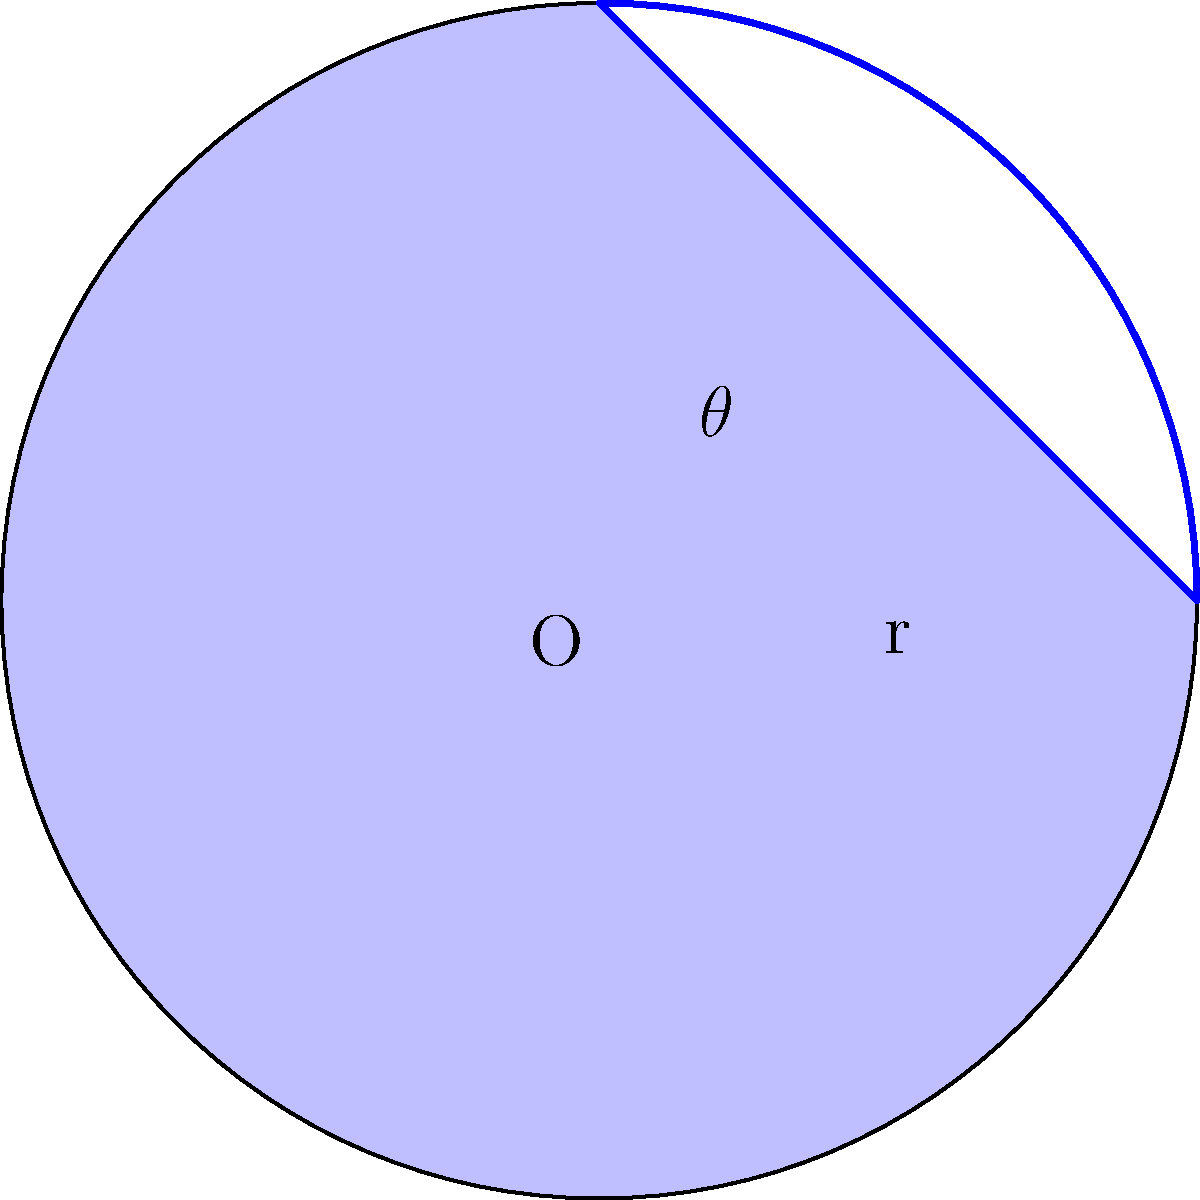In "Orlando," Tilda Swinton's character experiences time as fluid as the phases of the moon. Inspired by this imagery, consider a circular sector representing a crescent moon. If the radius of the full moon is 5 units and the central angle of the crescent is $\frac{\pi}{2}$ radians, what is the area of the crescent moon (the shaded region)? Let's approach this step-by-step:

1) The area of the crescent moon is the difference between the area of the sector and the area of the triangle formed by the chord and the two radii.

2) Area of the sector:
   $$A_{sector} = \frac{1}{2}r^2\theta$$
   where $r = 5$ and $\theta = \frac{\pi}{2}$
   $$A_{sector} = \frac{1}{2} \cdot 5^2 \cdot \frac{\pi}{2} = \frac{25\pi}{4}$$

3) Area of the triangle:
   $$A_{triangle} = \frac{1}{2}r^2\sin\theta$$
   $$A_{triangle} = \frac{1}{2} \cdot 5^2 \cdot \sin\frac{\pi}{2} = \frac{25}{2}$$

4) Area of the crescent:
   $$A_{crescent} = A_{sector} - A_{triangle}$$
   $$A_{crescent} = \frac{25\pi}{4} - \frac{25}{2}$$
   $$A_{crescent} = \frac{25\pi}{4} - \frac{25}{2} = \frac{25\pi - 50}{4}$$

5) Simplify:
   $$A_{crescent} = \frac{25(\pi - 2)}{4} \approx 6.85$$

Therefore, the area of the crescent moon is $\frac{25(\pi - 2)}{4}$ square units.
Answer: $\frac{25(\pi - 2)}{4}$ square units 